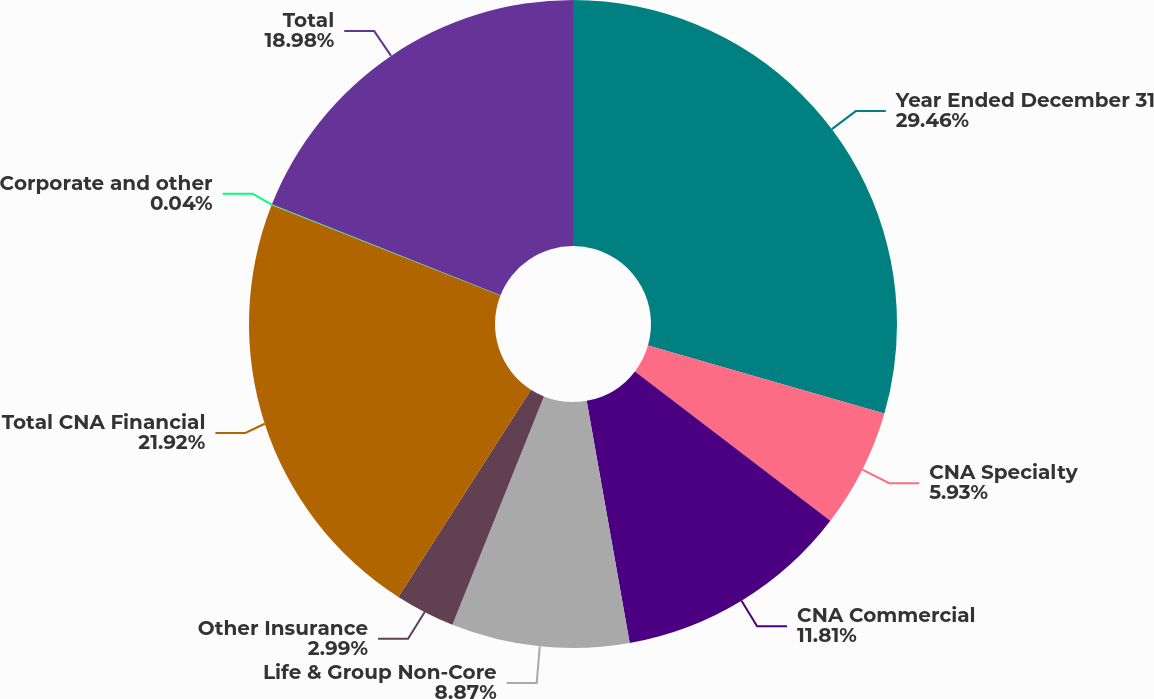Convert chart. <chart><loc_0><loc_0><loc_500><loc_500><pie_chart><fcel>Year Ended December 31<fcel>CNA Specialty<fcel>CNA Commercial<fcel>Life & Group Non-Core<fcel>Other Insurance<fcel>Total CNA Financial<fcel>Corporate and other<fcel>Total<nl><fcel>29.46%<fcel>5.93%<fcel>11.81%<fcel>8.87%<fcel>2.99%<fcel>21.92%<fcel>0.04%<fcel>18.98%<nl></chart> 